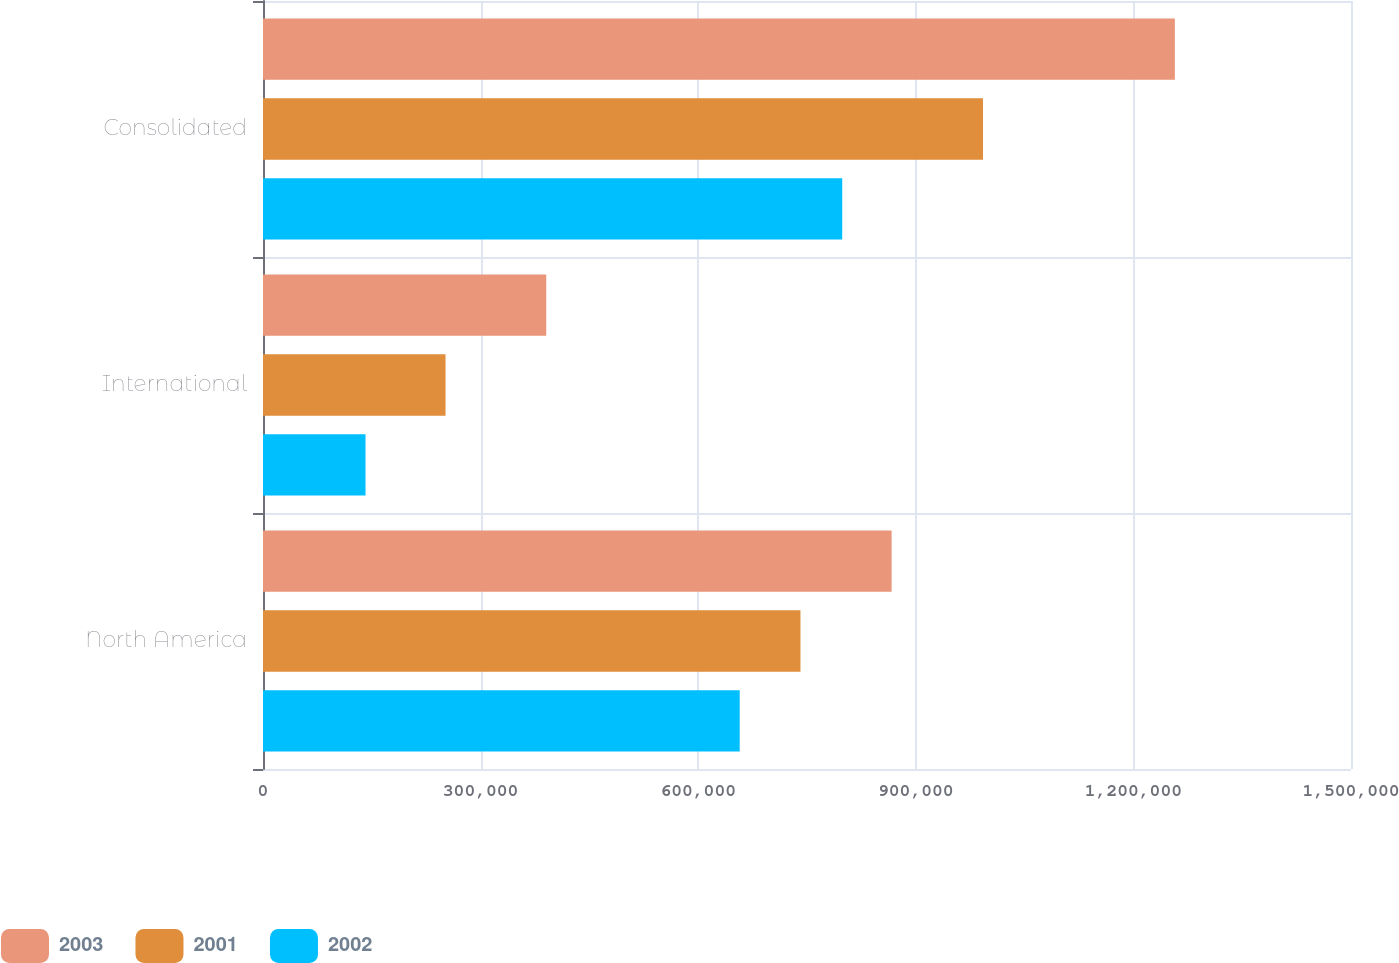Convert chart to OTSL. <chart><loc_0><loc_0><loc_500><loc_500><stacked_bar_chart><ecel><fcel>North America<fcel>International<fcel>Consolidated<nl><fcel>2003<fcel>866664<fcel>390504<fcel>1.25717e+06<nl><fcel>2001<fcel>740985<fcel>251633<fcel>992618<nl><fcel>2002<fcel>657229<fcel>141329<fcel>798558<nl></chart> 